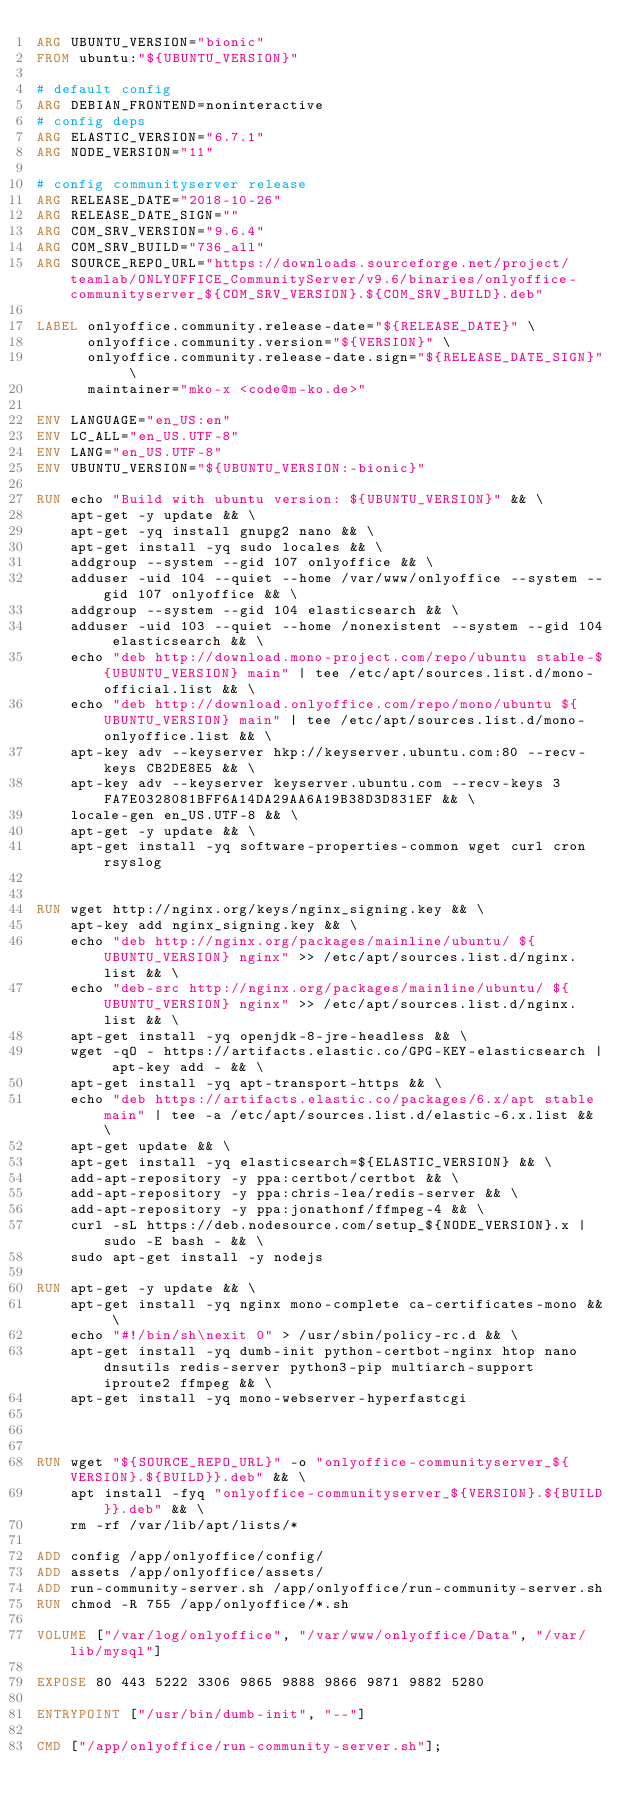Convert code to text. <code><loc_0><loc_0><loc_500><loc_500><_Dockerfile_>ARG UBUNTU_VERSION="bionic"
FROM ubuntu:"${UBUNTU_VERSION}"

# default config
ARG DEBIAN_FRONTEND=noninteractive
# config deps
ARG ELASTIC_VERSION="6.7.1"
ARG NODE_VERSION="11"

# config communityserver release
ARG RELEASE_DATE="2018-10-26"
ARG RELEASE_DATE_SIGN=""
ARG COM_SRV_VERSION="9.6.4"
ARG COM_SRV_BUILD="736_all"
ARG SOURCE_REPO_URL="https://downloads.sourceforge.net/project/teamlab/ONLYOFFICE_CommunityServer/v9.6/binaries/onlyoffice-communityserver_${COM_SRV_VERSION}.${COM_SRV_BUILD}.deb"

LABEL onlyoffice.community.release-date="${RELEASE_DATE}" \
      onlyoffice.community.version="${VERSION}" \
      onlyoffice.community.release-date.sign="${RELEASE_DATE_SIGN}" \
      maintainer="mko-x <code@m-ko.de>"

ENV LANGUAGE="en_US:en"
ENV	LC_ALL="en_US.UTF-8"
ENV	LANG="en_US.UTF-8"
ENV UBUNTU_VERSION="${UBUNTU_VERSION:-bionic}"
    
RUN echo "Build with ubuntu version: ${UBUNTU_VERSION}" && \
    apt-get -y update && \
    apt-get -yq install gnupg2 nano && \
    apt-get install -yq sudo locales && \
    addgroup --system --gid 107 onlyoffice && \
    adduser -uid 104 --quiet --home /var/www/onlyoffice --system --gid 107 onlyoffice && \
    addgroup --system --gid 104 elasticsearch && \
    adduser -uid 103 --quiet --home /nonexistent --system --gid 104 elasticsearch && \
    echo "deb http://download.mono-project.com/repo/ubuntu stable-${UBUNTU_VERSION} main" | tee /etc/apt/sources.list.d/mono-official.list && \
    echo "deb http://download.onlyoffice.com/repo/mono/ubuntu ${UBUNTU_VERSION} main" | tee /etc/apt/sources.list.d/mono-onlyoffice.list && \    
    apt-key adv --keyserver hkp://keyserver.ubuntu.com:80 --recv-keys CB2DE8E5 && \
    apt-key adv --keyserver keyserver.ubuntu.com --recv-keys 3FA7E0328081BFF6A14DA29AA6A19B38D3D831EF && \
    locale-gen en_US.UTF-8 && \
    apt-get -y update && \
    apt-get install -yq software-properties-common wget curl cron rsyslog


RUN wget http://nginx.org/keys/nginx_signing.key && \
    apt-key add nginx_signing.key && \
    echo "deb http://nginx.org/packages/mainline/ubuntu/ ${UBUNTU_VERSION} nginx" >> /etc/apt/sources.list.d/nginx.list && \
    echo "deb-src http://nginx.org/packages/mainline/ubuntu/ ${UBUNTU_VERSION} nginx" >> /etc/apt/sources.list.d/nginx.list && \
    apt-get install -yq openjdk-8-jre-headless && \
    wget -qO - https://artifacts.elastic.co/GPG-KEY-elasticsearch | apt-key add - && \
    apt-get install -yq apt-transport-https && \
    echo "deb https://artifacts.elastic.co/packages/6.x/apt stable main" | tee -a /etc/apt/sources.list.d/elastic-6.x.list && \
    apt-get update && \
    apt-get install -yq elasticsearch=${ELASTIC_VERSION} && \
    add-apt-repository -y ppa:certbot/certbot && \
    add-apt-repository -y ppa:chris-lea/redis-server && \
    add-apt-repository -y ppa:jonathonf/ffmpeg-4 && \
    curl -sL https://deb.nodesource.com/setup_${NODE_VERSION}.x | sudo -E bash - && \
    sudo apt-get install -y nodejs

RUN apt-get -y update && \
    apt-get install -yq nginx mono-complete ca-certificates-mono && \
    echo "#!/bin/sh\nexit 0" > /usr/sbin/policy-rc.d && \
    apt-get install -yq dumb-init python-certbot-nginx htop nano dnsutils redis-server python3-pip multiarch-support iproute2 ffmpeg && \
    apt-get install -yq mono-webserver-hyperfastcgi   
    


RUN wget "${SOURCE_REPO_URL}" -o "onlyoffice-communityserver_${VERSION}.${BUILD}}.deb" && \
    apt install -fyq "onlyoffice-communityserver_${VERSION}.${BUILD}}.deb" && \
    rm -rf /var/lib/apt/lists/*

ADD config /app/onlyoffice/config/
ADD assets /app/onlyoffice/assets/
ADD run-community-server.sh /app/onlyoffice/run-community-server.sh
RUN chmod -R 755 /app/onlyoffice/*.sh

VOLUME ["/var/log/onlyoffice", "/var/www/onlyoffice/Data", "/var/lib/mysql"]

EXPOSE 80 443 5222 3306 9865 9888 9866 9871 9882 5280

ENTRYPOINT ["/usr/bin/dumb-init", "--"]

CMD ["/app/onlyoffice/run-community-server.sh"];</code> 